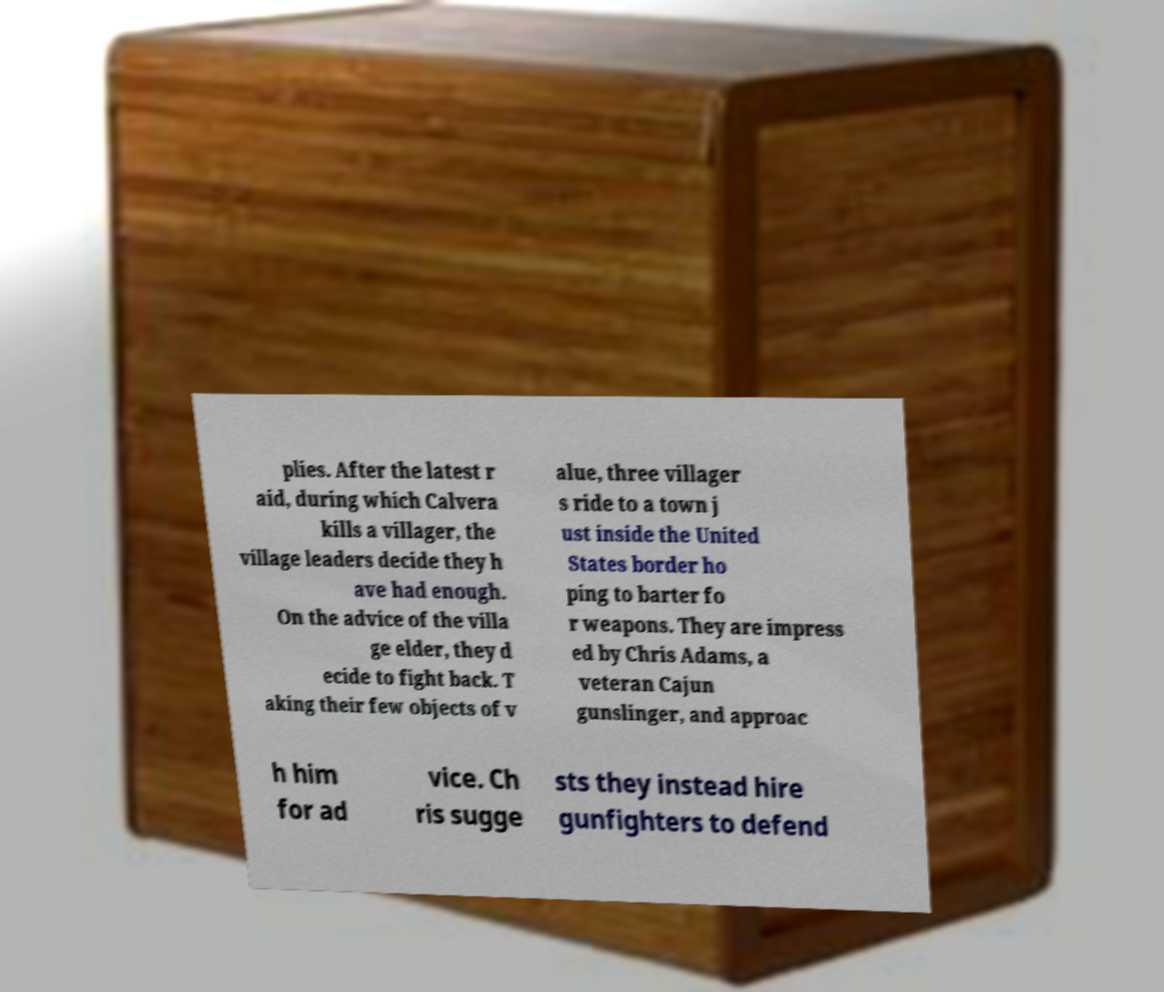Can you read and provide the text displayed in the image?This photo seems to have some interesting text. Can you extract and type it out for me? plies. After the latest r aid, during which Calvera kills a villager, the village leaders decide they h ave had enough. On the advice of the villa ge elder, they d ecide to fight back. T aking their few objects of v alue, three villager s ride to a town j ust inside the United States border ho ping to barter fo r weapons. They are impress ed by Chris Adams, a veteran Cajun gunslinger, and approac h him for ad vice. Ch ris sugge sts they instead hire gunfighters to defend 